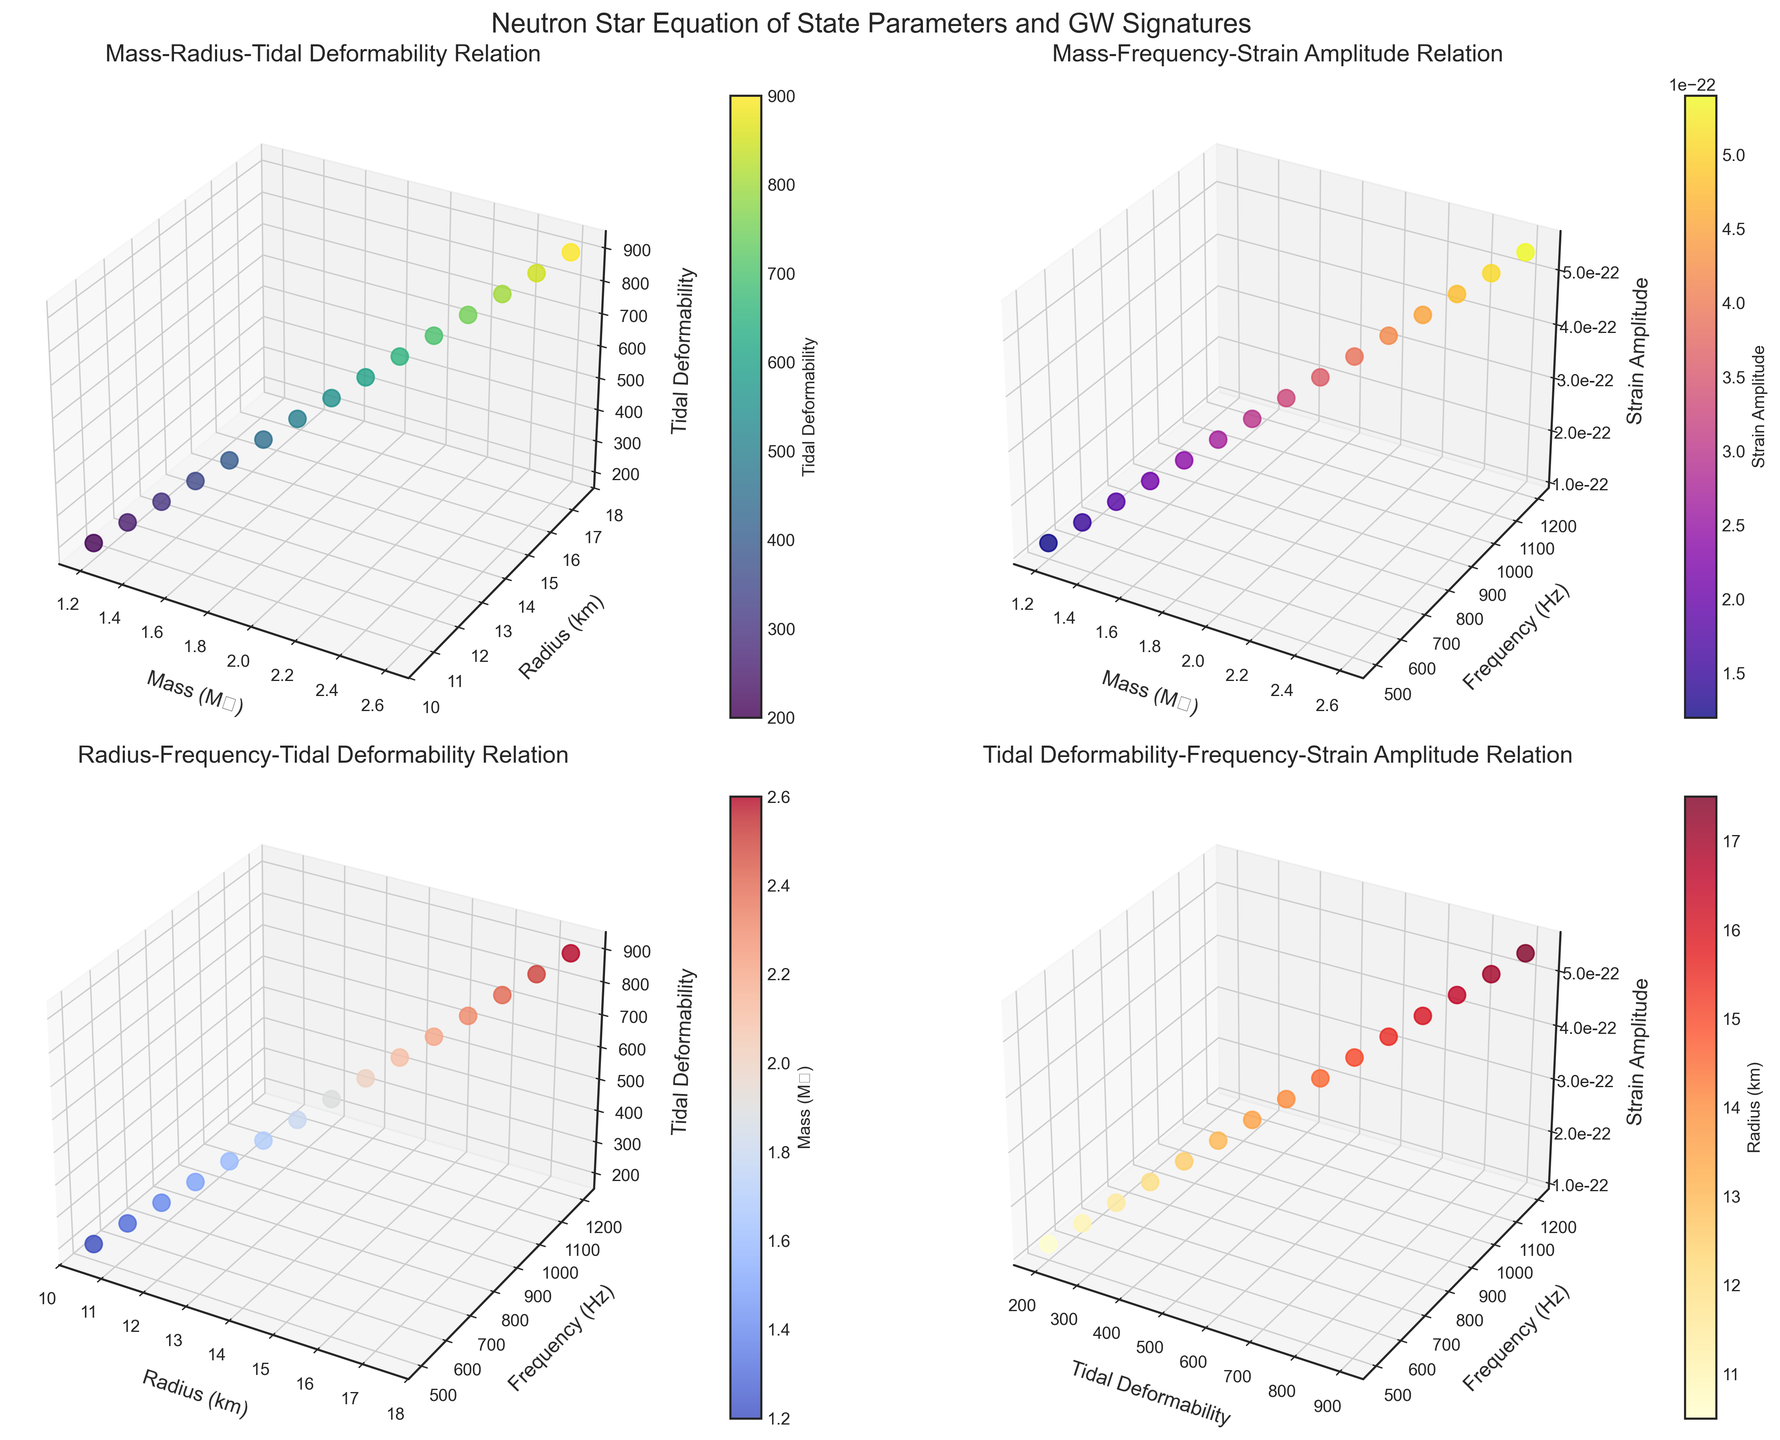What's the title of the entire figure? The title of the entire figure is shown in large text at the top of the figure. By identifying the largest, most prominently placed text at the top, we can read: "Neutron Star Equation of State Parameters and GW Signatures"
Answer: Neutron Star Equation of State Parameters and GW Signatures Which axis represents Tidal Deformability in the first subplot (Mass-Radius-Tidal Deformability Relation)? By looking at the labels on the axes in the first subplot, we can see that the Z-axis is labeled "Tidal Deformability". Therefore, the Z-axis represents Tidal Deformability
Answer: Z-axis What is the color of the highest Strain Amplitude in the second subplot (Mass-Frequency-Strain Amplitude Relation)? By looking at the color bar legend in the second subplot, we see that the highest Strain Amplitude value corresponds to the color at the extreme end of the color spectrum in the plasma colormap. This color typically resembles a dark purple hue
Answer: Dark purple How does the Radius change with increasing Tidal Deformability in the second subplot (Mass-Frequency-Strain Amplitude Relation)? To answer this, look at the distribution of radius values in the second subplot, denoted by colors on the color bar. As the Tidal Deformability increases, the associated Radius values also increase, going from lighter to darker colors on the YlOrRd color map
Answer: Increases What is the relationship between Frequency and Strain Amplitude in the third subplot (Radius-Frequency-Tidal Deformability Relation)? Examining the third subplot, we can see that as Frequency increases along the Y-axis, the Strain Amplitude (Z-axis) also increases. This indicates a positive correlation between Frequency and Strain Amplitude
Answer: Positive correlation Which parameter has the highest value in the fourth subplot (Tidal Deformability-Frequency-Strain Amplitude Relation) and what is its respective Radius? By looking at the fourth subplot and identifying the highest value on the X-axis (Tidal Deformability), we observe that it occurs at 900. The associated Radius value from the color bar is 17.5 km
Answer: 900 and 17.5 km Are there any data points that have a Mass (M☉) of 2.0 in any of the subplots? To determine this, we need to examine the scatter points across all subplots. Noticing the data points with Mass value of 2.0, we identify in multiple subplots - visually verifying in the Mass-Radius-Tidal Deformability and Mass-Frequency-Strain Amplitude subplots confirms this
Answer: Yes Comparing the highest mass values in the first and second plots, are they equal, less, or more than each other? The highest Mass value in each subplot should be checked. Both the first and second subplots indicate Mass values up to 2.6 M☉. Therefore, the highest Mass values are equal in both plots
Answer: Equal What general pattern of change do you observe in Strain Amplitude with increasing Tidal Deformability in the fourth plot? Observing the fourth subplot, as Tidal Deformability increases along the X-axis, Strain Amplitude on the Z-axis also increases. This suggests that higher Tidal Deformability values are associated with higher Strain Amplitude values
Answer: Increases 